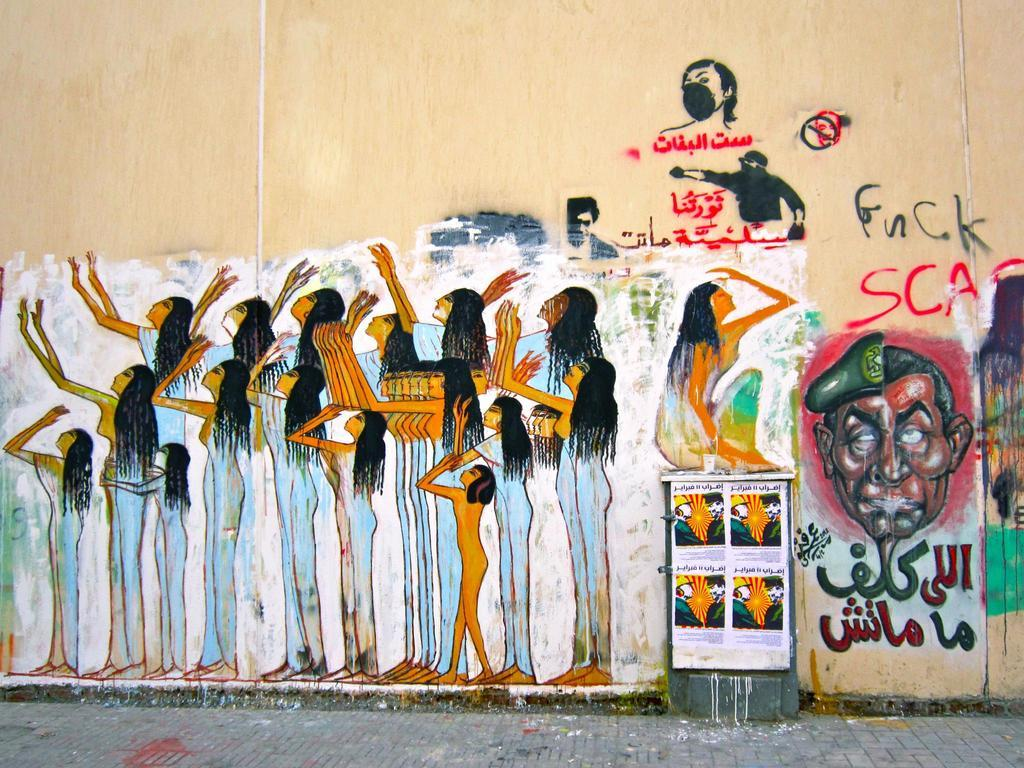What is present on the wall in the image? The wall has a painting on it. What does the painting depict? The painting depicts many women. What is located at the bottom of the image? There is a road at the bottom of the image. How many slaves are depicted in the painting on the wall? There are no slaves depicted in the painting on the wall, as the painting features many women. What type of uncle can be seen walking along the road at the bottom of the image? There is no uncle present in the image; it only shows a wall with a painting and a road at the bottom. 